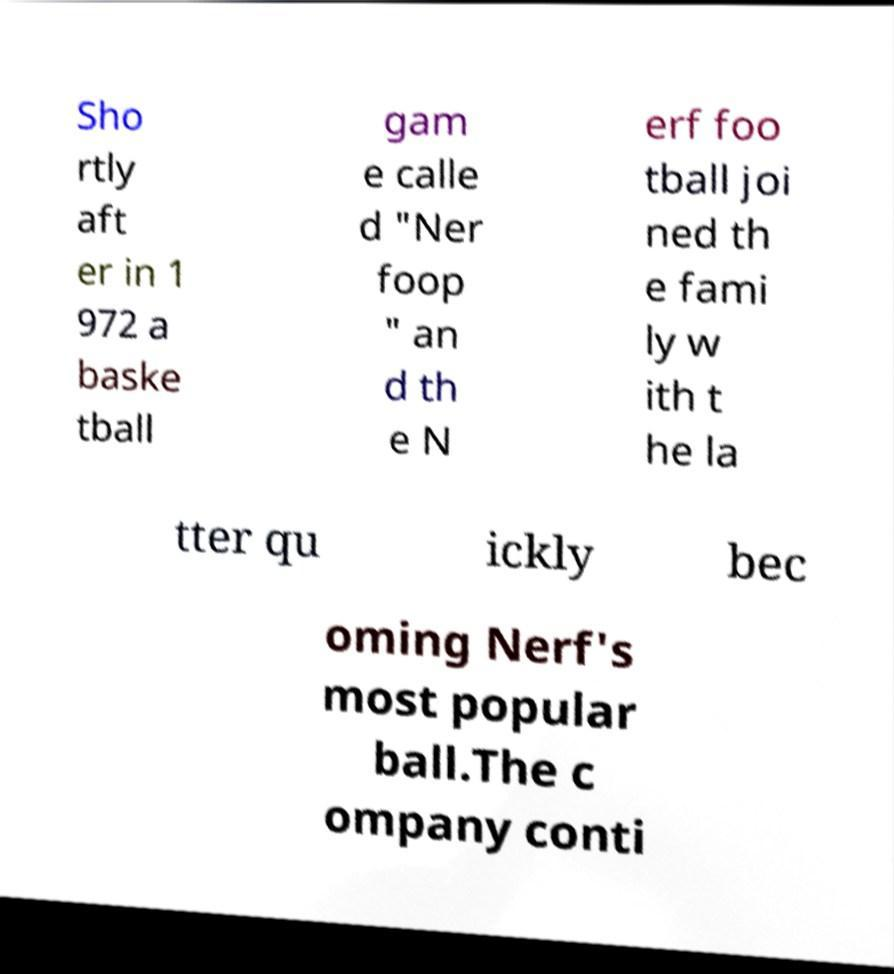What messages or text are displayed in this image? I need them in a readable, typed format. Sho rtly aft er in 1 972 a baske tball gam e calle d "Ner foop " an d th e N erf foo tball joi ned th e fami ly w ith t he la tter qu ickly bec oming Nerf's most popular ball.The c ompany conti 